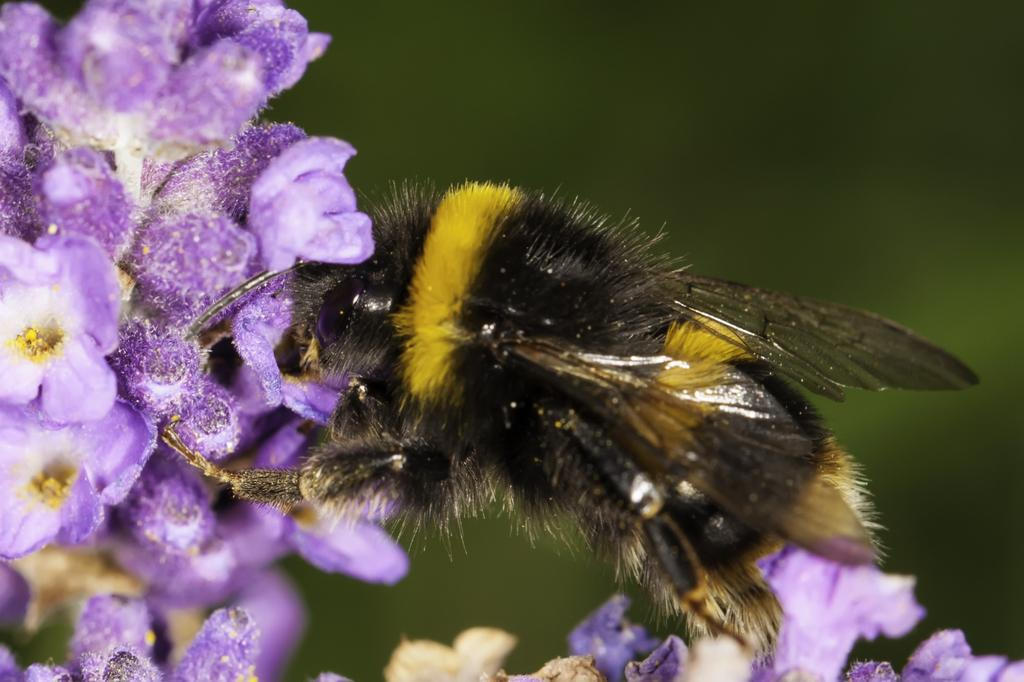What is the main subject of the image? The main subject of the image is a honey bee. Where is the honey bee located in the image? The honey bee is on flowers in the image. What color are the flowers the honey bee is on? The flowers are in violet color. What color is the background of the image? The background of the image is in green color. What can be seen at the bottom of the image? There are flowers and buds at the bottom of the image. What type of sand can be seen in the image? There is no sand present in the image; it features a honey bee on violet flowers with a green background. 